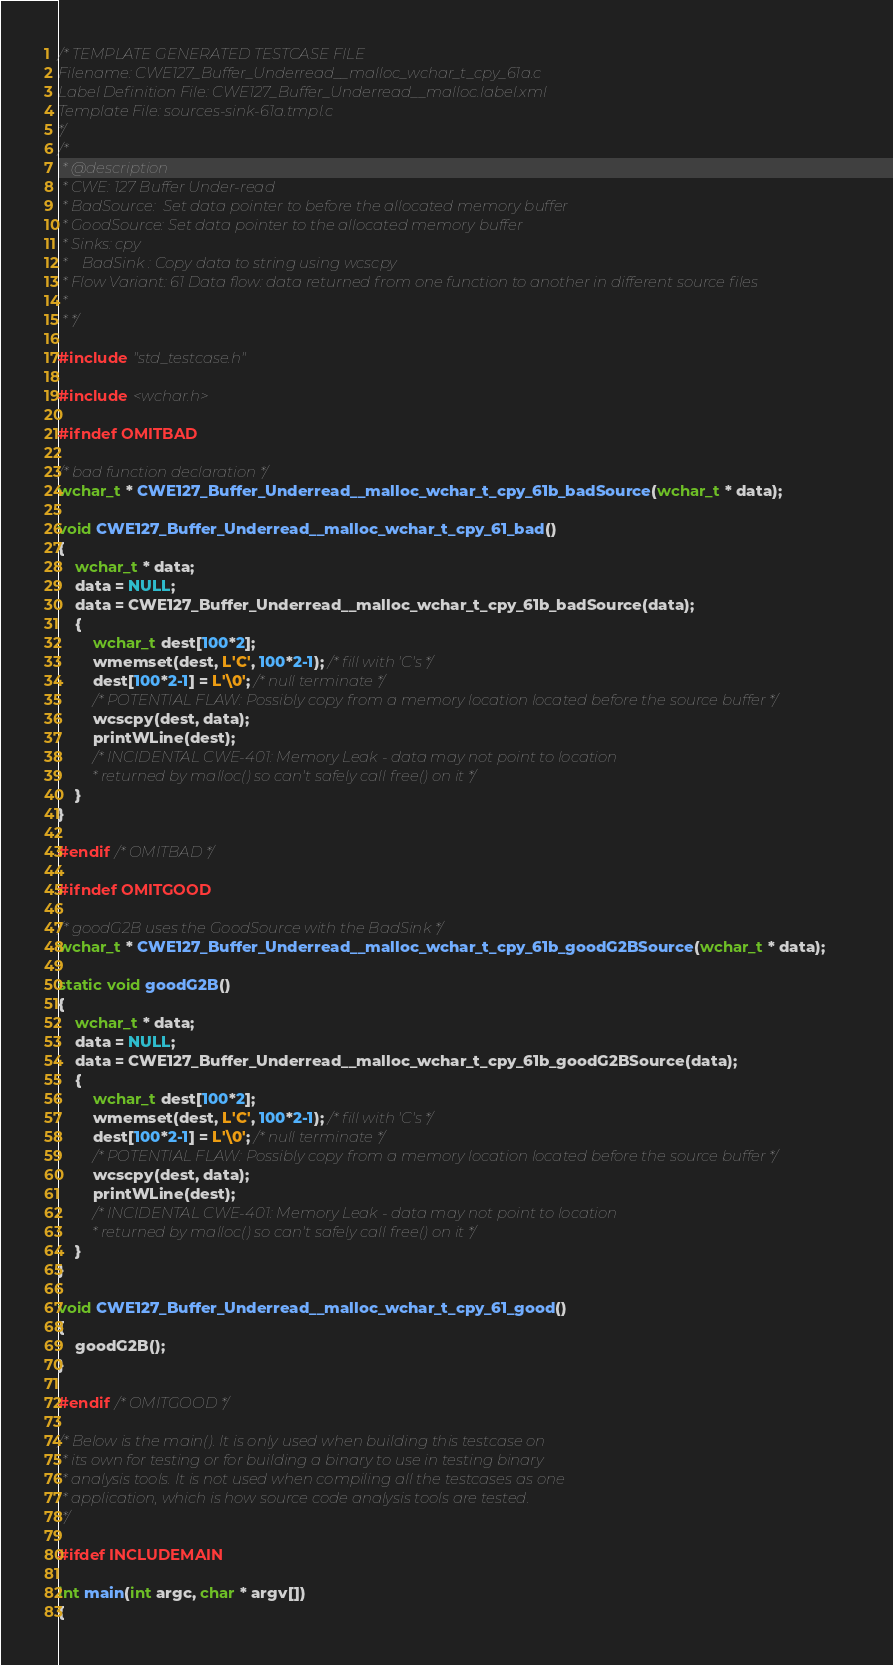<code> <loc_0><loc_0><loc_500><loc_500><_C_>/* TEMPLATE GENERATED TESTCASE FILE
Filename: CWE127_Buffer_Underread__malloc_wchar_t_cpy_61a.c
Label Definition File: CWE127_Buffer_Underread__malloc.label.xml
Template File: sources-sink-61a.tmpl.c
*/
/*
 * @description
 * CWE: 127 Buffer Under-read
 * BadSource:  Set data pointer to before the allocated memory buffer
 * GoodSource: Set data pointer to the allocated memory buffer
 * Sinks: cpy
 *    BadSink : Copy data to string using wcscpy
 * Flow Variant: 61 Data flow: data returned from one function to another in different source files
 *
 * */

#include "std_testcase.h"

#include <wchar.h>

#ifndef OMITBAD

/* bad function declaration */
wchar_t * CWE127_Buffer_Underread__malloc_wchar_t_cpy_61b_badSource(wchar_t * data);

void CWE127_Buffer_Underread__malloc_wchar_t_cpy_61_bad()
{
    wchar_t * data;
    data = NULL;
    data = CWE127_Buffer_Underread__malloc_wchar_t_cpy_61b_badSource(data);
    {
        wchar_t dest[100*2];
        wmemset(dest, L'C', 100*2-1); /* fill with 'C's */
        dest[100*2-1] = L'\0'; /* null terminate */
        /* POTENTIAL FLAW: Possibly copy from a memory location located before the source buffer */
        wcscpy(dest, data);
        printWLine(dest);
        /* INCIDENTAL CWE-401: Memory Leak - data may not point to location
         * returned by malloc() so can't safely call free() on it */
    }
}

#endif /* OMITBAD */

#ifndef OMITGOOD

/* goodG2B uses the GoodSource with the BadSink */
wchar_t * CWE127_Buffer_Underread__malloc_wchar_t_cpy_61b_goodG2BSource(wchar_t * data);

static void goodG2B()
{
    wchar_t * data;
    data = NULL;
    data = CWE127_Buffer_Underread__malloc_wchar_t_cpy_61b_goodG2BSource(data);
    {
        wchar_t dest[100*2];
        wmemset(dest, L'C', 100*2-1); /* fill with 'C's */
        dest[100*2-1] = L'\0'; /* null terminate */
        /* POTENTIAL FLAW: Possibly copy from a memory location located before the source buffer */
        wcscpy(dest, data);
        printWLine(dest);
        /* INCIDENTAL CWE-401: Memory Leak - data may not point to location
         * returned by malloc() so can't safely call free() on it */
    }
}

void CWE127_Buffer_Underread__malloc_wchar_t_cpy_61_good()
{
    goodG2B();
}

#endif /* OMITGOOD */

/* Below is the main(). It is only used when building this testcase on
 * its own for testing or for building a binary to use in testing binary
 * analysis tools. It is not used when compiling all the testcases as one
 * application, which is how source code analysis tools are tested.
 */

#ifdef INCLUDEMAIN

int main(int argc, char * argv[])
{</code> 